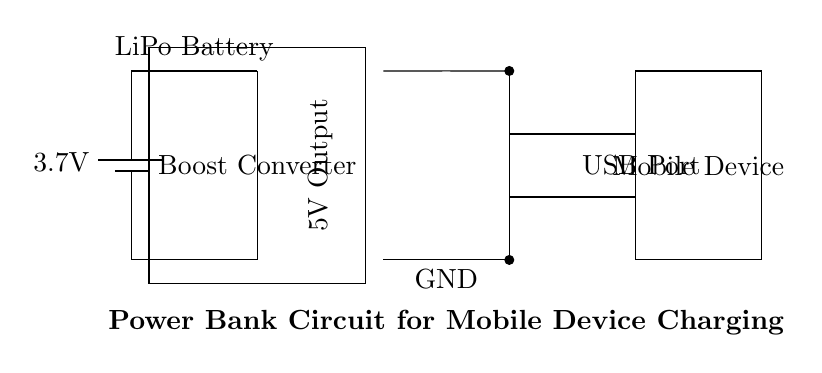What is the voltage of the battery? The battery in the circuit is labeled as 3.7V. This value indicates the potential difference provided by the battery to the rest of the circuit.
Answer: 3.7V What component boosts the voltage? The component that boosts the voltage in this circuit is labeled as the "Boost Converter." It takes the input voltage from the battery and increases it to a higher output voltage necessary for charging devices.
Answer: Boost Converter What is the output voltage provided to the mobile device? The output voltage provided to the mobile device is labeled as 5V. This indicates the voltage that is available for charging the mobile device from the power bank.
Answer: 5V Where does the power supply for the USB port come from? The power supply for the USB port comes from the Boost Converter, which converts the 3.7V from the battery to 5V. The circuit shows a connection from the output of the Boost Converter to the USB port.
Answer: Boost Converter What type of battery is being used in this circuit? The battery being used in this circuit is a Lithium Polymer (LiPo) battery, as indicated by its label in the diagram.
Answer: LiPo How is the mobile device connected to the circuit? The mobile device is connected to the circuit through the USB port, utilizing the output voltage provided at the port for charging. This connection includes two wires that link the USB port to the mobile device.
Answer: USB Port 